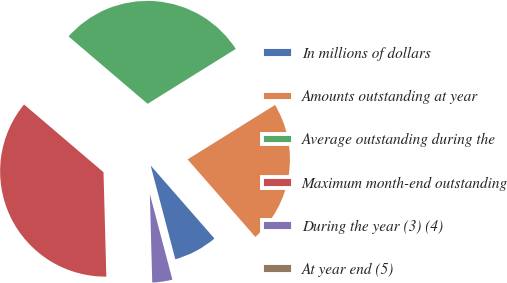<chart> <loc_0><loc_0><loc_500><loc_500><pie_chart><fcel>In millions of dollars<fcel>Amounts outstanding at year<fcel>Average outstanding during the<fcel>Maximum month-end outstanding<fcel>During the year (3) (4)<fcel>At year end (5)<nl><fcel>7.33%<fcel>22.43%<fcel>29.9%<fcel>36.67%<fcel>3.67%<fcel>0.0%<nl></chart> 